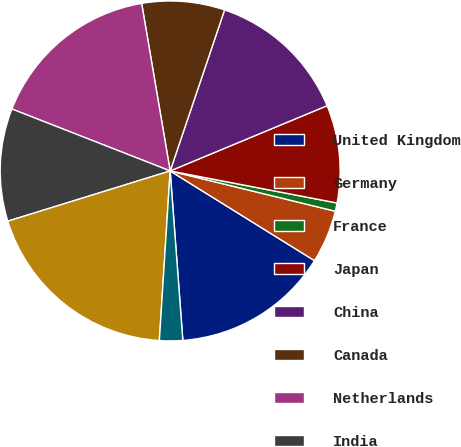Convert chart to OTSL. <chart><loc_0><loc_0><loc_500><loc_500><pie_chart><fcel>United Kingdom<fcel>Germany<fcel>France<fcel>Japan<fcel>China<fcel>Canada<fcel>Netherlands<fcel>India<fcel>Switzerland<fcel>Korea<nl><fcel>14.96%<fcel>5.04%<fcel>0.79%<fcel>9.29%<fcel>13.54%<fcel>7.87%<fcel>16.38%<fcel>10.71%<fcel>19.21%<fcel>2.2%<nl></chart> 